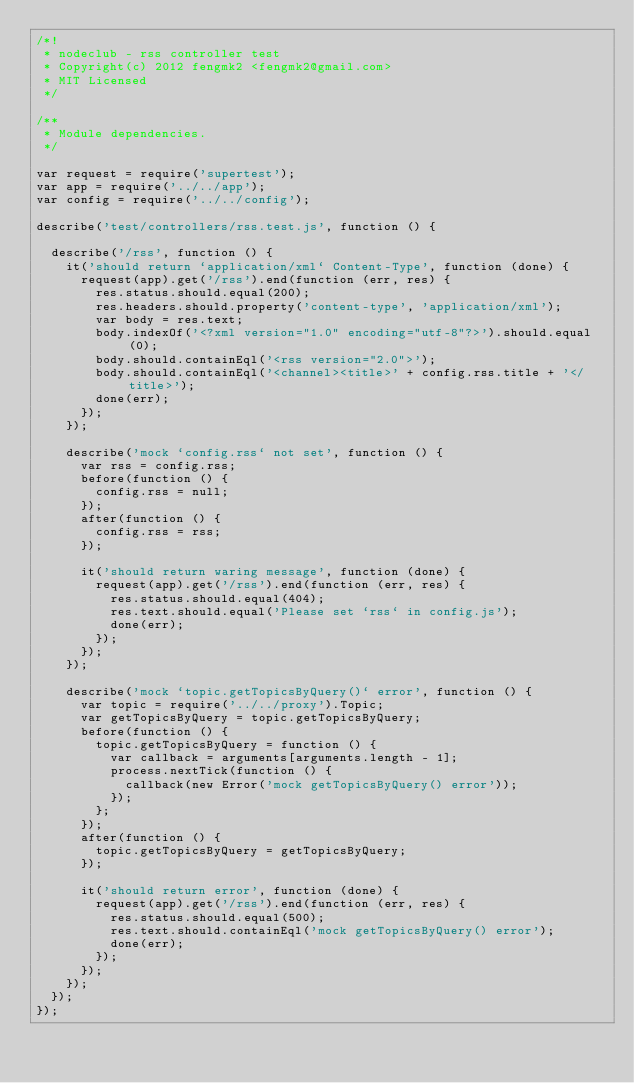Convert code to text. <code><loc_0><loc_0><loc_500><loc_500><_JavaScript_>/*!
 * nodeclub - rss controller test
 * Copyright(c) 2012 fengmk2 <fengmk2@gmail.com>
 * MIT Licensed
 */

/**
 * Module dependencies.
 */

var request = require('supertest');
var app = require('../../app');
var config = require('../../config');

describe('test/controllers/rss.test.js', function () {

  describe('/rss', function () {
    it('should return `application/xml` Content-Type', function (done) {
      request(app).get('/rss').end(function (err, res) {
        res.status.should.equal(200);
        res.headers.should.property('content-type', 'application/xml');
        var body = res.text;
        body.indexOf('<?xml version="1.0" encoding="utf-8"?>').should.equal(0);
        body.should.containEql('<rss version="2.0">');
        body.should.containEql('<channel><title>' + config.rss.title + '</title>');
        done(err);
      });
    });

    describe('mock `config.rss` not set', function () {
      var rss = config.rss;
      before(function () {
        config.rss = null;
      });
      after(function () {
        config.rss = rss;
      });

      it('should return waring message', function (done) {
        request(app).get('/rss').end(function (err, res) {
          res.status.should.equal(404);
          res.text.should.equal('Please set `rss` in config.js');
          done(err);
        });
      });
    });

    describe('mock `topic.getTopicsByQuery()` error', function () {
      var topic = require('../../proxy').Topic;
      var getTopicsByQuery = topic.getTopicsByQuery;
      before(function () {
        topic.getTopicsByQuery = function () {
          var callback = arguments[arguments.length - 1];
          process.nextTick(function () {
            callback(new Error('mock getTopicsByQuery() error'));
          });
        };
      });
      after(function () {
        topic.getTopicsByQuery = getTopicsByQuery;
      });

      it('should return error', function (done) {
        request(app).get('/rss').end(function (err, res) {
          res.status.should.equal(500);
          res.text.should.containEql('mock getTopicsByQuery() error');
          done(err);
        });
      });
    });
  });
});
</code> 